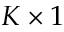Convert formula to latex. <formula><loc_0><loc_0><loc_500><loc_500>K \times 1</formula> 